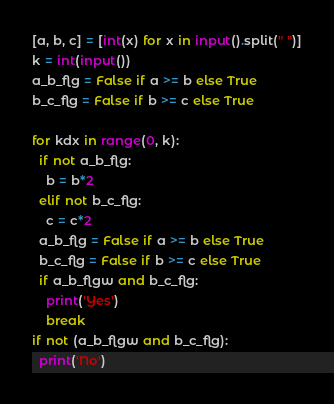<code> <loc_0><loc_0><loc_500><loc_500><_Python_>[a, b, c] = [int(x) for x in input().split(" ")]
k = int(input())
a_b_flg = False if a >= b else True
b_c_flg = False if b >= c else True

for kdx in range(0, k):
  if not a_b_flg:
    b = b*2
  elif not b_c_flg:
    c = c*2
  a_b_flg = False if a >= b else True
  b_c_flg = False if b >= c else True
  if a_b_flgw and b_c_flg:
    print('Yes')
    break
if not (a_b_flgw and b_c_flg):
  print('No')</code> 